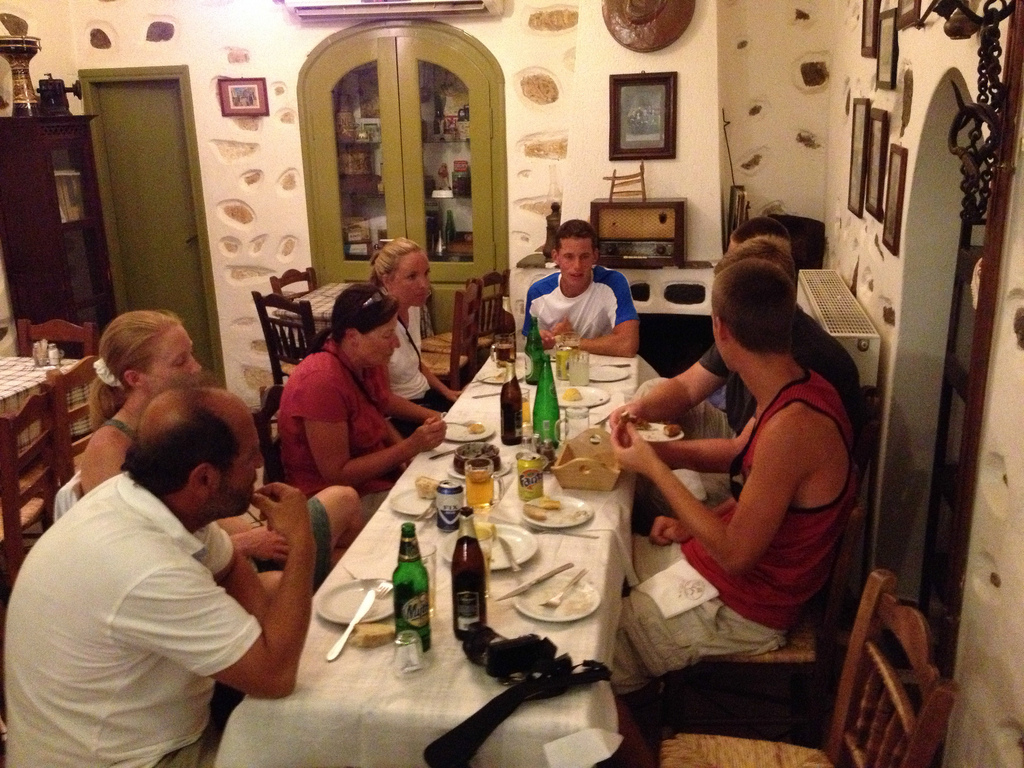Is the plate to the right or to the left of the bottle in the picture? The plate is to the right of the bottle, complementing the dining setup on the table. 